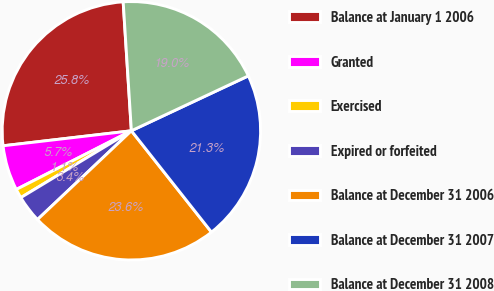Convert chart to OTSL. <chart><loc_0><loc_0><loc_500><loc_500><pie_chart><fcel>Balance at January 1 2006<fcel>Granted<fcel>Exercised<fcel>Expired or forfeited<fcel>Balance at December 31 2006<fcel>Balance at December 31 2007<fcel>Balance at December 31 2008<nl><fcel>25.84%<fcel>5.65%<fcel>1.15%<fcel>3.4%<fcel>23.59%<fcel>21.34%<fcel>19.03%<nl></chart> 